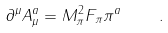<formula> <loc_0><loc_0><loc_500><loc_500>\partial ^ { \mu } A _ { \mu } ^ { a } = M _ { \pi } ^ { 2 } F _ { \pi } \pi ^ { a } \quad .</formula> 